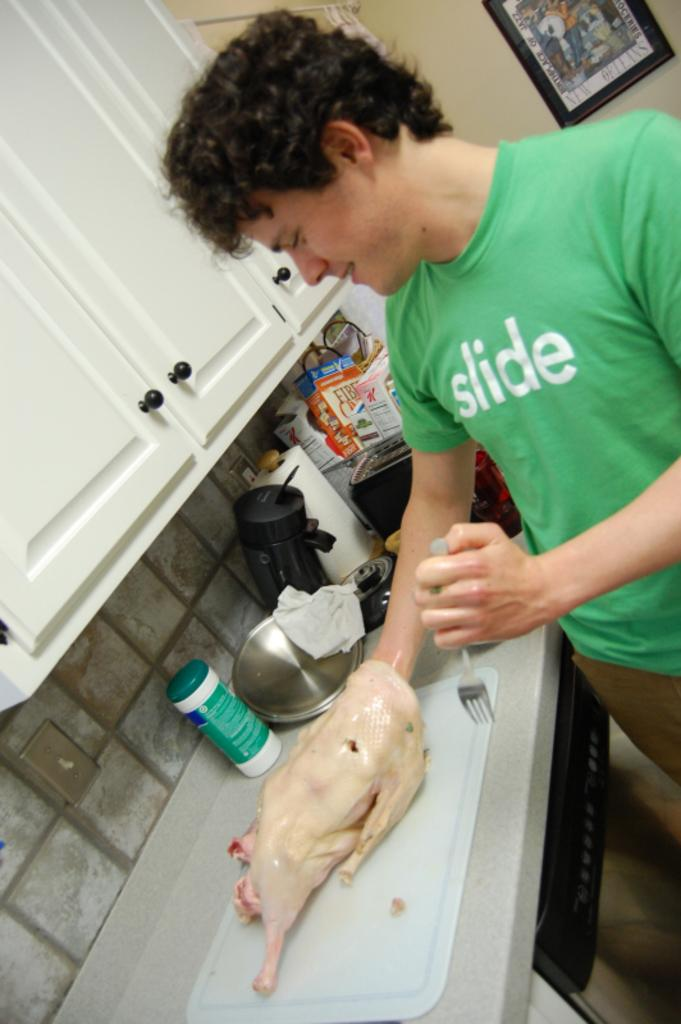Provide a one-sentence caption for the provided image. A man with a green shirt that reads "slide" is standing in a kitchen with his hand inside a plucked chicken on the counter. 